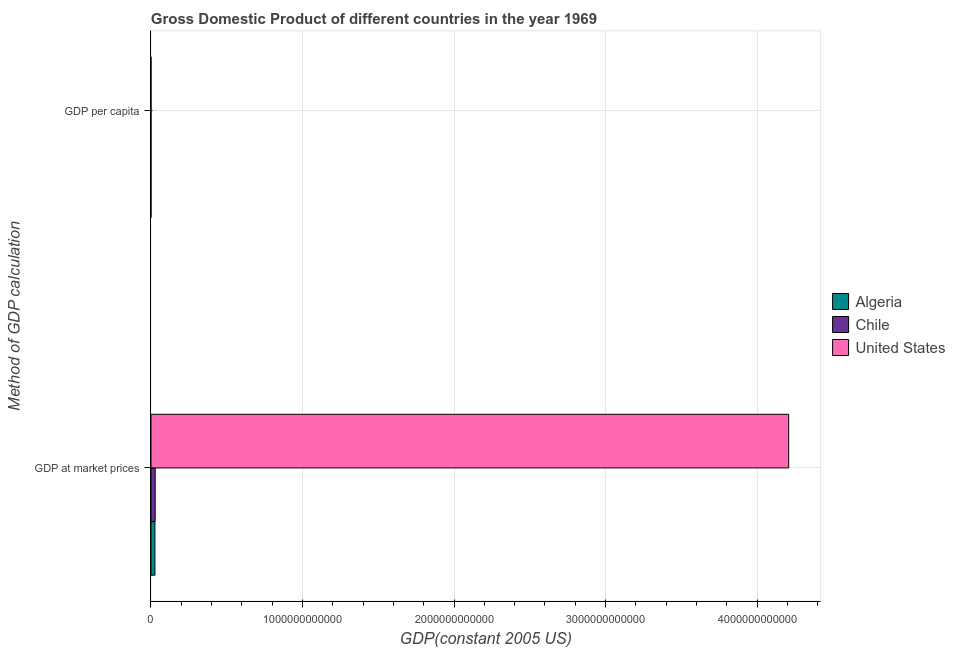How many different coloured bars are there?
Keep it short and to the point. 3. How many groups of bars are there?
Offer a terse response. 2. How many bars are there on the 1st tick from the top?
Ensure brevity in your answer.  3. What is the label of the 1st group of bars from the top?
Offer a very short reply. GDP per capita. What is the gdp per capita in Chile?
Ensure brevity in your answer.  2963.81. Across all countries, what is the maximum gdp at market prices?
Ensure brevity in your answer.  4.21e+12. Across all countries, what is the minimum gdp per capita?
Keep it short and to the point. 1846.12. In which country was the gdp at market prices minimum?
Your answer should be very brief. Algeria. What is the total gdp at market prices in the graph?
Your response must be concise. 4.26e+12. What is the difference between the gdp at market prices in Chile and that in Algeria?
Your response must be concise. 1.68e+09. What is the difference between the gdp per capita in Chile and the gdp at market prices in United States?
Make the answer very short. -4.21e+12. What is the average gdp per capita per country?
Provide a short and direct response. 8525.15. What is the difference between the gdp at market prices and gdp per capita in Algeria?
Your answer should be very brief. 2.61e+1. In how many countries, is the gdp at market prices greater than 1400000000000 US$?
Keep it short and to the point. 1. What is the ratio of the gdp at market prices in Chile to that in United States?
Offer a very short reply. 0.01. Is the gdp at market prices in Algeria less than that in Chile?
Your response must be concise. Yes. What does the 2nd bar from the top in GDP at market prices represents?
Offer a very short reply. Chile. What does the 2nd bar from the bottom in GDP per capita represents?
Provide a short and direct response. Chile. How many bars are there?
Give a very brief answer. 6. Are all the bars in the graph horizontal?
Your answer should be compact. Yes. How many countries are there in the graph?
Offer a terse response. 3. What is the difference between two consecutive major ticks on the X-axis?
Your answer should be compact. 1.00e+12. Where does the legend appear in the graph?
Ensure brevity in your answer.  Center right. What is the title of the graph?
Offer a very short reply. Gross Domestic Product of different countries in the year 1969. Does "Saudi Arabia" appear as one of the legend labels in the graph?
Keep it short and to the point. No. What is the label or title of the X-axis?
Keep it short and to the point. GDP(constant 2005 US). What is the label or title of the Y-axis?
Provide a short and direct response. Method of GDP calculation. What is the GDP(constant 2005 US) in Algeria in GDP at market prices?
Your answer should be very brief. 2.61e+1. What is the GDP(constant 2005 US) in Chile in GDP at market prices?
Ensure brevity in your answer.  2.78e+1. What is the GDP(constant 2005 US) in United States in GDP at market prices?
Provide a succinct answer. 4.21e+12. What is the GDP(constant 2005 US) of Algeria in GDP per capita?
Ensure brevity in your answer.  1846.12. What is the GDP(constant 2005 US) of Chile in GDP per capita?
Provide a succinct answer. 2963.81. What is the GDP(constant 2005 US) of United States in GDP per capita?
Give a very brief answer. 2.08e+04. Across all Method of GDP calculation, what is the maximum GDP(constant 2005 US) of Algeria?
Keep it short and to the point. 2.61e+1. Across all Method of GDP calculation, what is the maximum GDP(constant 2005 US) of Chile?
Your answer should be compact. 2.78e+1. Across all Method of GDP calculation, what is the maximum GDP(constant 2005 US) of United States?
Give a very brief answer. 4.21e+12. Across all Method of GDP calculation, what is the minimum GDP(constant 2005 US) of Algeria?
Make the answer very short. 1846.12. Across all Method of GDP calculation, what is the minimum GDP(constant 2005 US) of Chile?
Provide a short and direct response. 2963.81. Across all Method of GDP calculation, what is the minimum GDP(constant 2005 US) of United States?
Offer a very short reply. 2.08e+04. What is the total GDP(constant 2005 US) in Algeria in the graph?
Keep it short and to the point. 2.61e+1. What is the total GDP(constant 2005 US) of Chile in the graph?
Offer a terse response. 2.78e+1. What is the total GDP(constant 2005 US) of United States in the graph?
Give a very brief answer. 4.21e+12. What is the difference between the GDP(constant 2005 US) in Algeria in GDP at market prices and that in GDP per capita?
Your response must be concise. 2.61e+1. What is the difference between the GDP(constant 2005 US) of Chile in GDP at market prices and that in GDP per capita?
Offer a very short reply. 2.78e+1. What is the difference between the GDP(constant 2005 US) of United States in GDP at market prices and that in GDP per capita?
Offer a very short reply. 4.21e+12. What is the difference between the GDP(constant 2005 US) in Algeria in GDP at market prices and the GDP(constant 2005 US) in Chile in GDP per capita?
Your response must be concise. 2.61e+1. What is the difference between the GDP(constant 2005 US) in Algeria in GDP at market prices and the GDP(constant 2005 US) in United States in GDP per capita?
Ensure brevity in your answer.  2.61e+1. What is the difference between the GDP(constant 2005 US) in Chile in GDP at market prices and the GDP(constant 2005 US) in United States in GDP per capita?
Your answer should be compact. 2.78e+1. What is the average GDP(constant 2005 US) in Algeria per Method of GDP calculation?
Provide a short and direct response. 1.31e+1. What is the average GDP(constant 2005 US) of Chile per Method of GDP calculation?
Offer a very short reply. 1.39e+1. What is the average GDP(constant 2005 US) in United States per Method of GDP calculation?
Provide a short and direct response. 2.10e+12. What is the difference between the GDP(constant 2005 US) of Algeria and GDP(constant 2005 US) of Chile in GDP at market prices?
Your answer should be very brief. -1.68e+09. What is the difference between the GDP(constant 2005 US) in Algeria and GDP(constant 2005 US) in United States in GDP at market prices?
Offer a very short reply. -4.18e+12. What is the difference between the GDP(constant 2005 US) of Chile and GDP(constant 2005 US) of United States in GDP at market prices?
Your answer should be compact. -4.18e+12. What is the difference between the GDP(constant 2005 US) in Algeria and GDP(constant 2005 US) in Chile in GDP per capita?
Your answer should be very brief. -1117.69. What is the difference between the GDP(constant 2005 US) in Algeria and GDP(constant 2005 US) in United States in GDP per capita?
Give a very brief answer. -1.89e+04. What is the difference between the GDP(constant 2005 US) in Chile and GDP(constant 2005 US) in United States in GDP per capita?
Provide a succinct answer. -1.78e+04. What is the ratio of the GDP(constant 2005 US) in Algeria in GDP at market prices to that in GDP per capita?
Give a very brief answer. 1.41e+07. What is the ratio of the GDP(constant 2005 US) in Chile in GDP at market prices to that in GDP per capita?
Ensure brevity in your answer.  9.38e+06. What is the ratio of the GDP(constant 2005 US) of United States in GDP at market prices to that in GDP per capita?
Keep it short and to the point. 2.03e+08. What is the difference between the highest and the second highest GDP(constant 2005 US) of Algeria?
Your answer should be very brief. 2.61e+1. What is the difference between the highest and the second highest GDP(constant 2005 US) in Chile?
Make the answer very short. 2.78e+1. What is the difference between the highest and the second highest GDP(constant 2005 US) in United States?
Provide a short and direct response. 4.21e+12. What is the difference between the highest and the lowest GDP(constant 2005 US) in Algeria?
Your answer should be very brief. 2.61e+1. What is the difference between the highest and the lowest GDP(constant 2005 US) of Chile?
Ensure brevity in your answer.  2.78e+1. What is the difference between the highest and the lowest GDP(constant 2005 US) in United States?
Provide a succinct answer. 4.21e+12. 